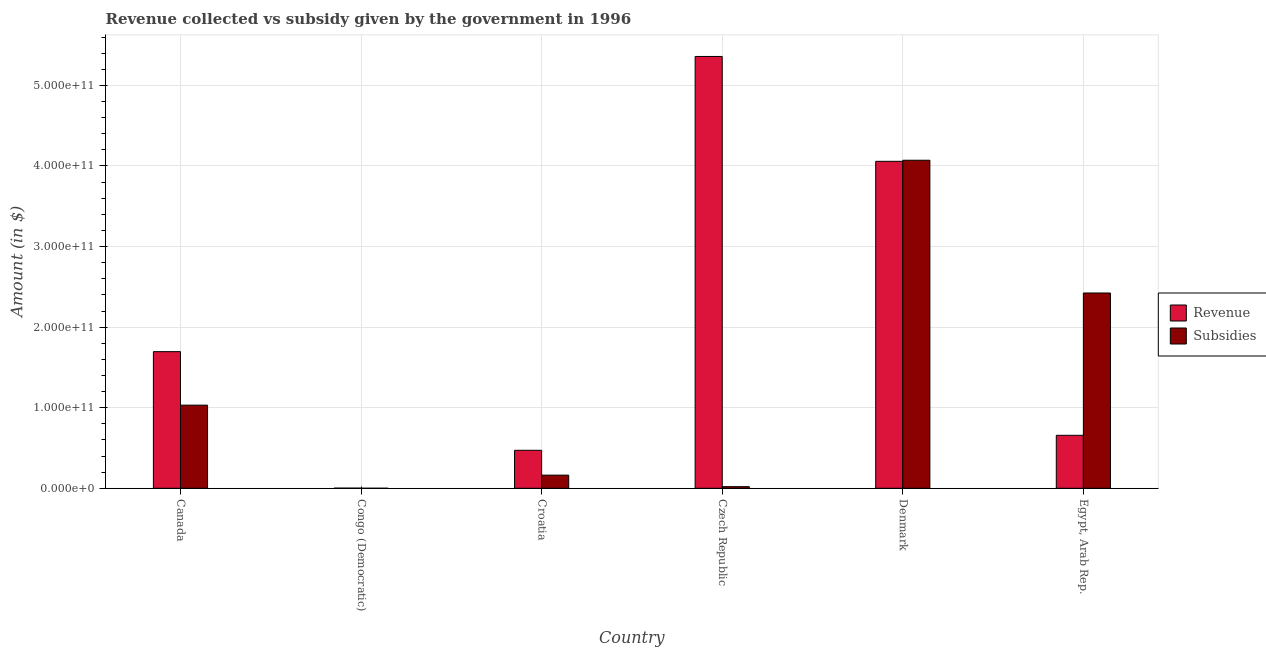How many groups of bars are there?
Ensure brevity in your answer.  6. How many bars are there on the 5th tick from the left?
Your answer should be compact. 2. How many bars are there on the 4th tick from the right?
Your response must be concise. 2. What is the label of the 4th group of bars from the left?
Give a very brief answer. Czech Republic. What is the amount of revenue collected in Czech Republic?
Your answer should be compact. 5.36e+11. Across all countries, what is the maximum amount of revenue collected?
Provide a succinct answer. 5.36e+11. Across all countries, what is the minimum amount of subsidies given?
Your response must be concise. 1.51e+06. In which country was the amount of revenue collected minimum?
Give a very brief answer. Congo (Democratic). What is the total amount of subsidies given in the graph?
Your answer should be compact. 7.71e+11. What is the difference between the amount of revenue collected in Croatia and that in Denmark?
Keep it short and to the point. -3.59e+11. What is the difference between the amount of subsidies given in Denmark and the amount of revenue collected in Croatia?
Make the answer very short. 3.60e+11. What is the average amount of subsidies given per country?
Provide a succinct answer. 1.28e+11. What is the difference between the amount of subsidies given and amount of revenue collected in Croatia?
Ensure brevity in your answer.  -3.08e+1. What is the ratio of the amount of subsidies given in Canada to that in Congo (Democratic)?
Provide a short and direct response. 6.83e+04. What is the difference between the highest and the second highest amount of revenue collected?
Provide a succinct answer. 1.30e+11. What is the difference between the highest and the lowest amount of subsidies given?
Provide a succinct answer. 4.07e+11. What does the 1st bar from the left in Denmark represents?
Your answer should be very brief. Revenue. What does the 1st bar from the right in Egypt, Arab Rep. represents?
Make the answer very short. Subsidies. How many bars are there?
Your answer should be compact. 12. What is the difference between two consecutive major ticks on the Y-axis?
Provide a succinct answer. 1.00e+11. Are the values on the major ticks of Y-axis written in scientific E-notation?
Provide a succinct answer. Yes. Does the graph contain any zero values?
Your response must be concise. No. Does the graph contain grids?
Make the answer very short. Yes. Where does the legend appear in the graph?
Ensure brevity in your answer.  Center right. How many legend labels are there?
Give a very brief answer. 2. What is the title of the graph?
Keep it short and to the point. Revenue collected vs subsidy given by the government in 1996. What is the label or title of the Y-axis?
Provide a succinct answer. Amount (in $). What is the Amount (in $) in Revenue in Canada?
Give a very brief answer. 1.70e+11. What is the Amount (in $) of Subsidies in Canada?
Your response must be concise. 1.03e+11. What is the Amount (in $) of Revenue in Congo (Democratic)?
Keep it short and to the point. 1.57e+08. What is the Amount (in $) in Subsidies in Congo (Democratic)?
Provide a succinct answer. 1.51e+06. What is the Amount (in $) in Revenue in Croatia?
Provide a succinct answer. 4.71e+1. What is the Amount (in $) of Subsidies in Croatia?
Ensure brevity in your answer.  1.63e+1. What is the Amount (in $) in Revenue in Czech Republic?
Your answer should be very brief. 5.36e+11. What is the Amount (in $) of Subsidies in Czech Republic?
Your response must be concise. 2.01e+09. What is the Amount (in $) of Revenue in Denmark?
Your answer should be very brief. 4.06e+11. What is the Amount (in $) in Subsidies in Denmark?
Your answer should be compact. 4.07e+11. What is the Amount (in $) of Revenue in Egypt, Arab Rep.?
Offer a terse response. 6.58e+1. What is the Amount (in $) of Subsidies in Egypt, Arab Rep.?
Offer a very short reply. 2.42e+11. Across all countries, what is the maximum Amount (in $) in Revenue?
Your response must be concise. 5.36e+11. Across all countries, what is the maximum Amount (in $) in Subsidies?
Provide a short and direct response. 4.07e+11. Across all countries, what is the minimum Amount (in $) of Revenue?
Provide a succinct answer. 1.57e+08. Across all countries, what is the minimum Amount (in $) in Subsidies?
Ensure brevity in your answer.  1.51e+06. What is the total Amount (in $) in Revenue in the graph?
Make the answer very short. 1.22e+12. What is the total Amount (in $) in Subsidies in the graph?
Make the answer very short. 7.71e+11. What is the difference between the Amount (in $) in Revenue in Canada and that in Congo (Democratic)?
Offer a terse response. 1.69e+11. What is the difference between the Amount (in $) of Subsidies in Canada and that in Congo (Democratic)?
Your response must be concise. 1.03e+11. What is the difference between the Amount (in $) of Revenue in Canada and that in Croatia?
Offer a very short reply. 1.22e+11. What is the difference between the Amount (in $) of Subsidies in Canada and that in Croatia?
Offer a very short reply. 8.68e+1. What is the difference between the Amount (in $) in Revenue in Canada and that in Czech Republic?
Provide a succinct answer. -3.66e+11. What is the difference between the Amount (in $) of Subsidies in Canada and that in Czech Republic?
Your answer should be very brief. 1.01e+11. What is the difference between the Amount (in $) of Revenue in Canada and that in Denmark?
Make the answer very short. -2.36e+11. What is the difference between the Amount (in $) in Subsidies in Canada and that in Denmark?
Your answer should be very brief. -3.04e+11. What is the difference between the Amount (in $) in Revenue in Canada and that in Egypt, Arab Rep.?
Offer a very short reply. 1.04e+11. What is the difference between the Amount (in $) of Subsidies in Canada and that in Egypt, Arab Rep.?
Keep it short and to the point. -1.39e+11. What is the difference between the Amount (in $) of Revenue in Congo (Democratic) and that in Croatia?
Give a very brief answer. -4.70e+1. What is the difference between the Amount (in $) of Subsidies in Congo (Democratic) and that in Croatia?
Provide a succinct answer. -1.63e+1. What is the difference between the Amount (in $) of Revenue in Congo (Democratic) and that in Czech Republic?
Keep it short and to the point. -5.36e+11. What is the difference between the Amount (in $) in Subsidies in Congo (Democratic) and that in Czech Republic?
Offer a very short reply. -2.01e+09. What is the difference between the Amount (in $) of Revenue in Congo (Democratic) and that in Denmark?
Ensure brevity in your answer.  -4.06e+11. What is the difference between the Amount (in $) in Subsidies in Congo (Democratic) and that in Denmark?
Offer a very short reply. -4.07e+11. What is the difference between the Amount (in $) of Revenue in Congo (Democratic) and that in Egypt, Arab Rep.?
Your answer should be compact. -6.56e+1. What is the difference between the Amount (in $) of Subsidies in Congo (Democratic) and that in Egypt, Arab Rep.?
Give a very brief answer. -2.42e+11. What is the difference between the Amount (in $) in Revenue in Croatia and that in Czech Republic?
Provide a succinct answer. -4.89e+11. What is the difference between the Amount (in $) in Subsidies in Croatia and that in Czech Republic?
Provide a succinct answer. 1.43e+1. What is the difference between the Amount (in $) of Revenue in Croatia and that in Denmark?
Provide a succinct answer. -3.59e+11. What is the difference between the Amount (in $) in Subsidies in Croatia and that in Denmark?
Give a very brief answer. -3.91e+11. What is the difference between the Amount (in $) of Revenue in Croatia and that in Egypt, Arab Rep.?
Ensure brevity in your answer.  -1.86e+1. What is the difference between the Amount (in $) in Subsidies in Croatia and that in Egypt, Arab Rep.?
Keep it short and to the point. -2.26e+11. What is the difference between the Amount (in $) of Revenue in Czech Republic and that in Denmark?
Your answer should be compact. 1.30e+11. What is the difference between the Amount (in $) of Subsidies in Czech Republic and that in Denmark?
Your answer should be very brief. -4.05e+11. What is the difference between the Amount (in $) of Revenue in Czech Republic and that in Egypt, Arab Rep.?
Provide a succinct answer. 4.70e+11. What is the difference between the Amount (in $) in Subsidies in Czech Republic and that in Egypt, Arab Rep.?
Your answer should be very brief. -2.40e+11. What is the difference between the Amount (in $) in Revenue in Denmark and that in Egypt, Arab Rep.?
Your answer should be very brief. 3.40e+11. What is the difference between the Amount (in $) in Subsidies in Denmark and that in Egypt, Arab Rep.?
Offer a terse response. 1.65e+11. What is the difference between the Amount (in $) in Revenue in Canada and the Amount (in $) in Subsidies in Congo (Democratic)?
Offer a very short reply. 1.70e+11. What is the difference between the Amount (in $) in Revenue in Canada and the Amount (in $) in Subsidies in Croatia?
Give a very brief answer. 1.53e+11. What is the difference between the Amount (in $) of Revenue in Canada and the Amount (in $) of Subsidies in Czech Republic?
Give a very brief answer. 1.68e+11. What is the difference between the Amount (in $) of Revenue in Canada and the Amount (in $) of Subsidies in Denmark?
Provide a short and direct response. -2.38e+11. What is the difference between the Amount (in $) in Revenue in Canada and the Amount (in $) in Subsidies in Egypt, Arab Rep.?
Provide a short and direct response. -7.28e+1. What is the difference between the Amount (in $) of Revenue in Congo (Democratic) and the Amount (in $) of Subsidies in Croatia?
Keep it short and to the point. -1.62e+1. What is the difference between the Amount (in $) in Revenue in Congo (Democratic) and the Amount (in $) in Subsidies in Czech Republic?
Provide a succinct answer. -1.86e+09. What is the difference between the Amount (in $) in Revenue in Congo (Democratic) and the Amount (in $) in Subsidies in Denmark?
Provide a succinct answer. -4.07e+11. What is the difference between the Amount (in $) of Revenue in Congo (Democratic) and the Amount (in $) of Subsidies in Egypt, Arab Rep.?
Offer a terse response. -2.42e+11. What is the difference between the Amount (in $) of Revenue in Croatia and the Amount (in $) of Subsidies in Czech Republic?
Keep it short and to the point. 4.51e+1. What is the difference between the Amount (in $) in Revenue in Croatia and the Amount (in $) in Subsidies in Denmark?
Your answer should be very brief. -3.60e+11. What is the difference between the Amount (in $) of Revenue in Croatia and the Amount (in $) of Subsidies in Egypt, Arab Rep.?
Make the answer very short. -1.95e+11. What is the difference between the Amount (in $) in Revenue in Czech Republic and the Amount (in $) in Subsidies in Denmark?
Your answer should be compact. 1.29e+11. What is the difference between the Amount (in $) in Revenue in Czech Republic and the Amount (in $) in Subsidies in Egypt, Arab Rep.?
Provide a succinct answer. 2.94e+11. What is the difference between the Amount (in $) in Revenue in Denmark and the Amount (in $) in Subsidies in Egypt, Arab Rep.?
Provide a short and direct response. 1.63e+11. What is the average Amount (in $) of Revenue per country?
Your response must be concise. 2.04e+11. What is the average Amount (in $) in Subsidies per country?
Offer a very short reply. 1.28e+11. What is the difference between the Amount (in $) of Revenue and Amount (in $) of Subsidies in Canada?
Your response must be concise. 6.64e+1. What is the difference between the Amount (in $) in Revenue and Amount (in $) in Subsidies in Congo (Democratic)?
Provide a short and direct response. 1.55e+08. What is the difference between the Amount (in $) in Revenue and Amount (in $) in Subsidies in Croatia?
Keep it short and to the point. 3.08e+1. What is the difference between the Amount (in $) of Revenue and Amount (in $) of Subsidies in Czech Republic?
Your answer should be compact. 5.34e+11. What is the difference between the Amount (in $) of Revenue and Amount (in $) of Subsidies in Denmark?
Offer a terse response. -1.33e+09. What is the difference between the Amount (in $) in Revenue and Amount (in $) in Subsidies in Egypt, Arab Rep.?
Give a very brief answer. -1.77e+11. What is the ratio of the Amount (in $) of Revenue in Canada to that in Congo (Democratic)?
Keep it short and to the point. 1080.86. What is the ratio of the Amount (in $) of Subsidies in Canada to that in Congo (Democratic)?
Provide a succinct answer. 6.83e+04. What is the ratio of the Amount (in $) in Revenue in Canada to that in Croatia?
Ensure brevity in your answer.  3.6. What is the ratio of the Amount (in $) of Subsidies in Canada to that in Croatia?
Offer a very short reply. 6.32. What is the ratio of the Amount (in $) in Revenue in Canada to that in Czech Republic?
Provide a short and direct response. 0.32. What is the ratio of the Amount (in $) in Subsidies in Canada to that in Czech Republic?
Offer a very short reply. 51.26. What is the ratio of the Amount (in $) of Revenue in Canada to that in Denmark?
Ensure brevity in your answer.  0.42. What is the ratio of the Amount (in $) in Subsidies in Canada to that in Denmark?
Offer a terse response. 0.25. What is the ratio of the Amount (in $) of Revenue in Canada to that in Egypt, Arab Rep.?
Make the answer very short. 2.58. What is the ratio of the Amount (in $) of Subsidies in Canada to that in Egypt, Arab Rep.?
Offer a terse response. 0.43. What is the ratio of the Amount (in $) in Revenue in Congo (Democratic) to that in Croatia?
Provide a succinct answer. 0. What is the ratio of the Amount (in $) of Subsidies in Congo (Democratic) to that in Czech Republic?
Offer a terse response. 0. What is the ratio of the Amount (in $) in Revenue in Congo (Democratic) to that in Denmark?
Your response must be concise. 0. What is the ratio of the Amount (in $) in Subsidies in Congo (Democratic) to that in Denmark?
Make the answer very short. 0. What is the ratio of the Amount (in $) of Revenue in Congo (Democratic) to that in Egypt, Arab Rep.?
Your answer should be compact. 0. What is the ratio of the Amount (in $) in Revenue in Croatia to that in Czech Republic?
Your answer should be compact. 0.09. What is the ratio of the Amount (in $) of Subsidies in Croatia to that in Czech Republic?
Your answer should be very brief. 8.11. What is the ratio of the Amount (in $) of Revenue in Croatia to that in Denmark?
Give a very brief answer. 0.12. What is the ratio of the Amount (in $) in Subsidies in Croatia to that in Denmark?
Your response must be concise. 0.04. What is the ratio of the Amount (in $) in Revenue in Croatia to that in Egypt, Arab Rep.?
Offer a very short reply. 0.72. What is the ratio of the Amount (in $) in Subsidies in Croatia to that in Egypt, Arab Rep.?
Provide a short and direct response. 0.07. What is the ratio of the Amount (in $) in Revenue in Czech Republic to that in Denmark?
Your answer should be very brief. 1.32. What is the ratio of the Amount (in $) in Subsidies in Czech Republic to that in Denmark?
Offer a terse response. 0. What is the ratio of the Amount (in $) in Revenue in Czech Republic to that in Egypt, Arab Rep.?
Your response must be concise. 8.15. What is the ratio of the Amount (in $) in Subsidies in Czech Republic to that in Egypt, Arab Rep.?
Make the answer very short. 0.01. What is the ratio of the Amount (in $) of Revenue in Denmark to that in Egypt, Arab Rep.?
Keep it short and to the point. 6.17. What is the ratio of the Amount (in $) in Subsidies in Denmark to that in Egypt, Arab Rep.?
Your answer should be very brief. 1.68. What is the difference between the highest and the second highest Amount (in $) of Revenue?
Provide a succinct answer. 1.30e+11. What is the difference between the highest and the second highest Amount (in $) in Subsidies?
Offer a terse response. 1.65e+11. What is the difference between the highest and the lowest Amount (in $) of Revenue?
Offer a very short reply. 5.36e+11. What is the difference between the highest and the lowest Amount (in $) of Subsidies?
Give a very brief answer. 4.07e+11. 